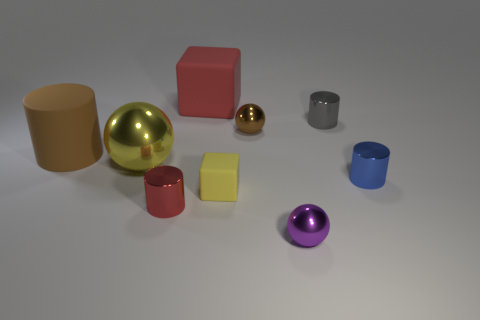How many objects are the same color as the big cylinder?
Keep it short and to the point. 1. There is a small metal object that is to the left of the big matte object that is behind the small cylinder that is behind the brown cylinder; what color is it?
Offer a terse response. Red. What color is the shiny ball that is the same size as the purple object?
Your response must be concise. Brown. How many shiny things are either brown cylinders or large brown balls?
Your response must be concise. 0. The big ball that is the same material as the small brown ball is what color?
Your answer should be very brief. Yellow. There is a tiny ball that is behind the matte cube that is in front of the small blue cylinder; what is it made of?
Give a very brief answer. Metal. What number of things are either big objects in front of the large cylinder or large yellow things that are to the left of the brown metal thing?
Offer a very short reply. 1. How big is the brown object that is on the right side of the red object that is in front of the brown thing behind the large cylinder?
Keep it short and to the point. Small. Are there an equal number of tiny yellow blocks that are behind the large metal sphere and tiny cyan objects?
Keep it short and to the point. Yes. There is a gray shiny thing; is its shape the same as the big matte thing that is in front of the gray metal cylinder?
Make the answer very short. Yes. 